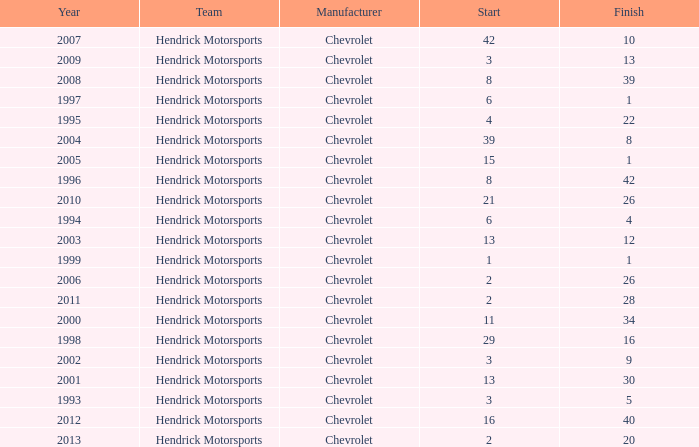What was Jeff's finish in 2011? 28.0. 